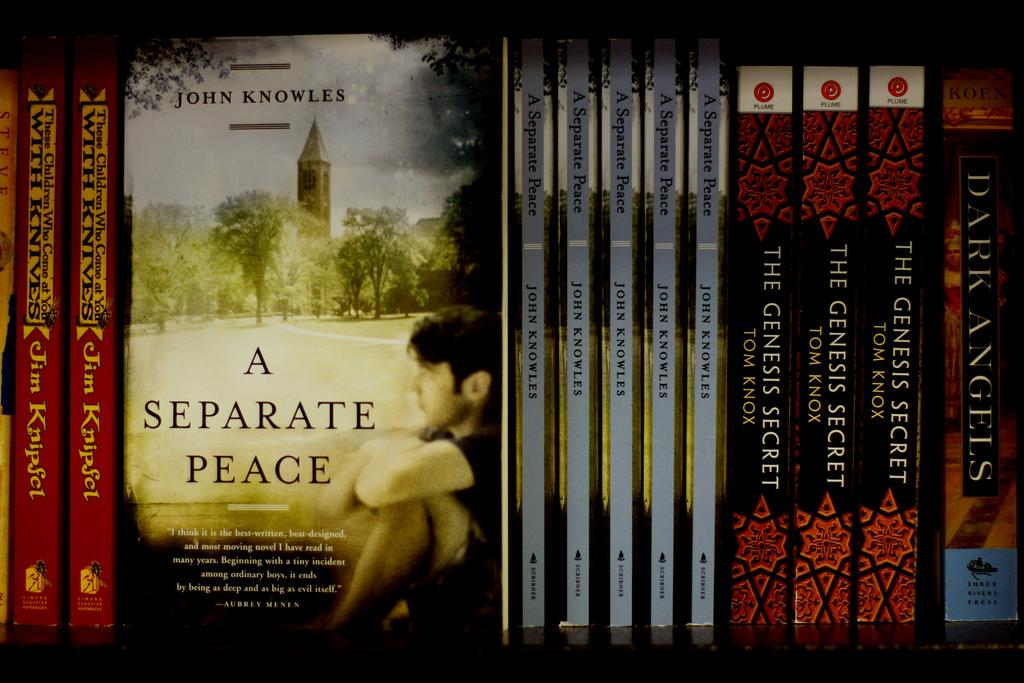<image>
Describe the image concisely. books like A separate Peace and The Genesis Secret lined up on a shelf 